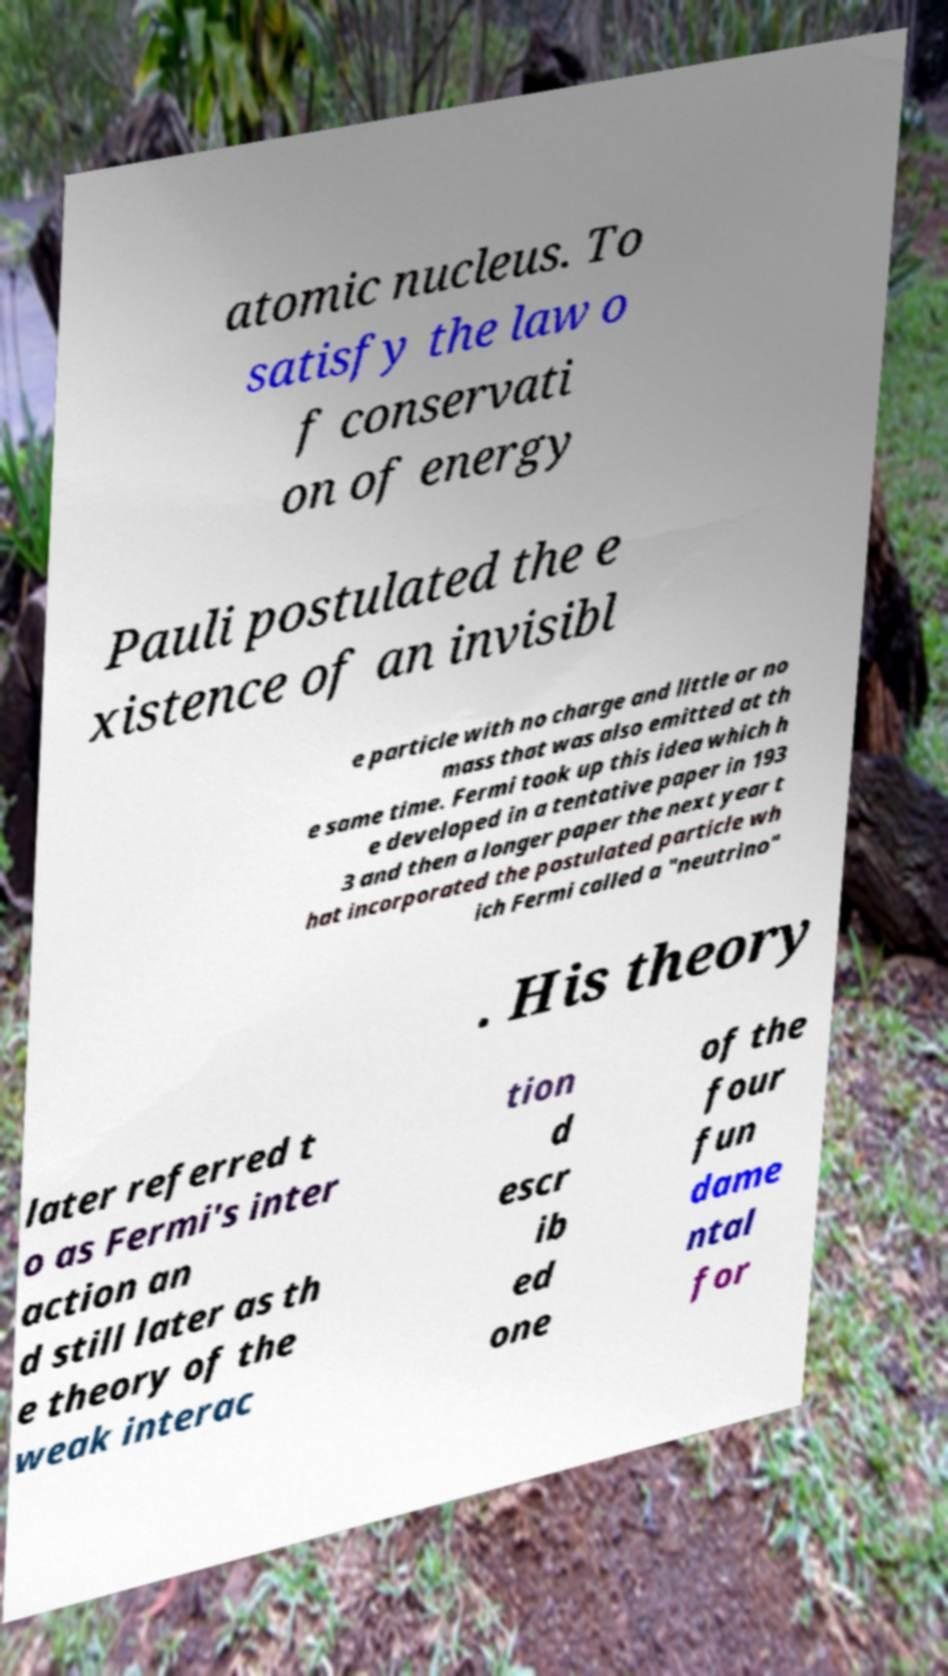What messages or text are displayed in this image? I need them in a readable, typed format. atomic nucleus. To satisfy the law o f conservati on of energy Pauli postulated the e xistence of an invisibl e particle with no charge and little or no mass that was also emitted at th e same time. Fermi took up this idea which h e developed in a tentative paper in 193 3 and then a longer paper the next year t hat incorporated the postulated particle wh ich Fermi called a "neutrino" . His theory later referred t o as Fermi's inter action an d still later as th e theory of the weak interac tion d escr ib ed one of the four fun dame ntal for 